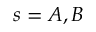<formula> <loc_0><loc_0><loc_500><loc_500>s = A , B</formula> 